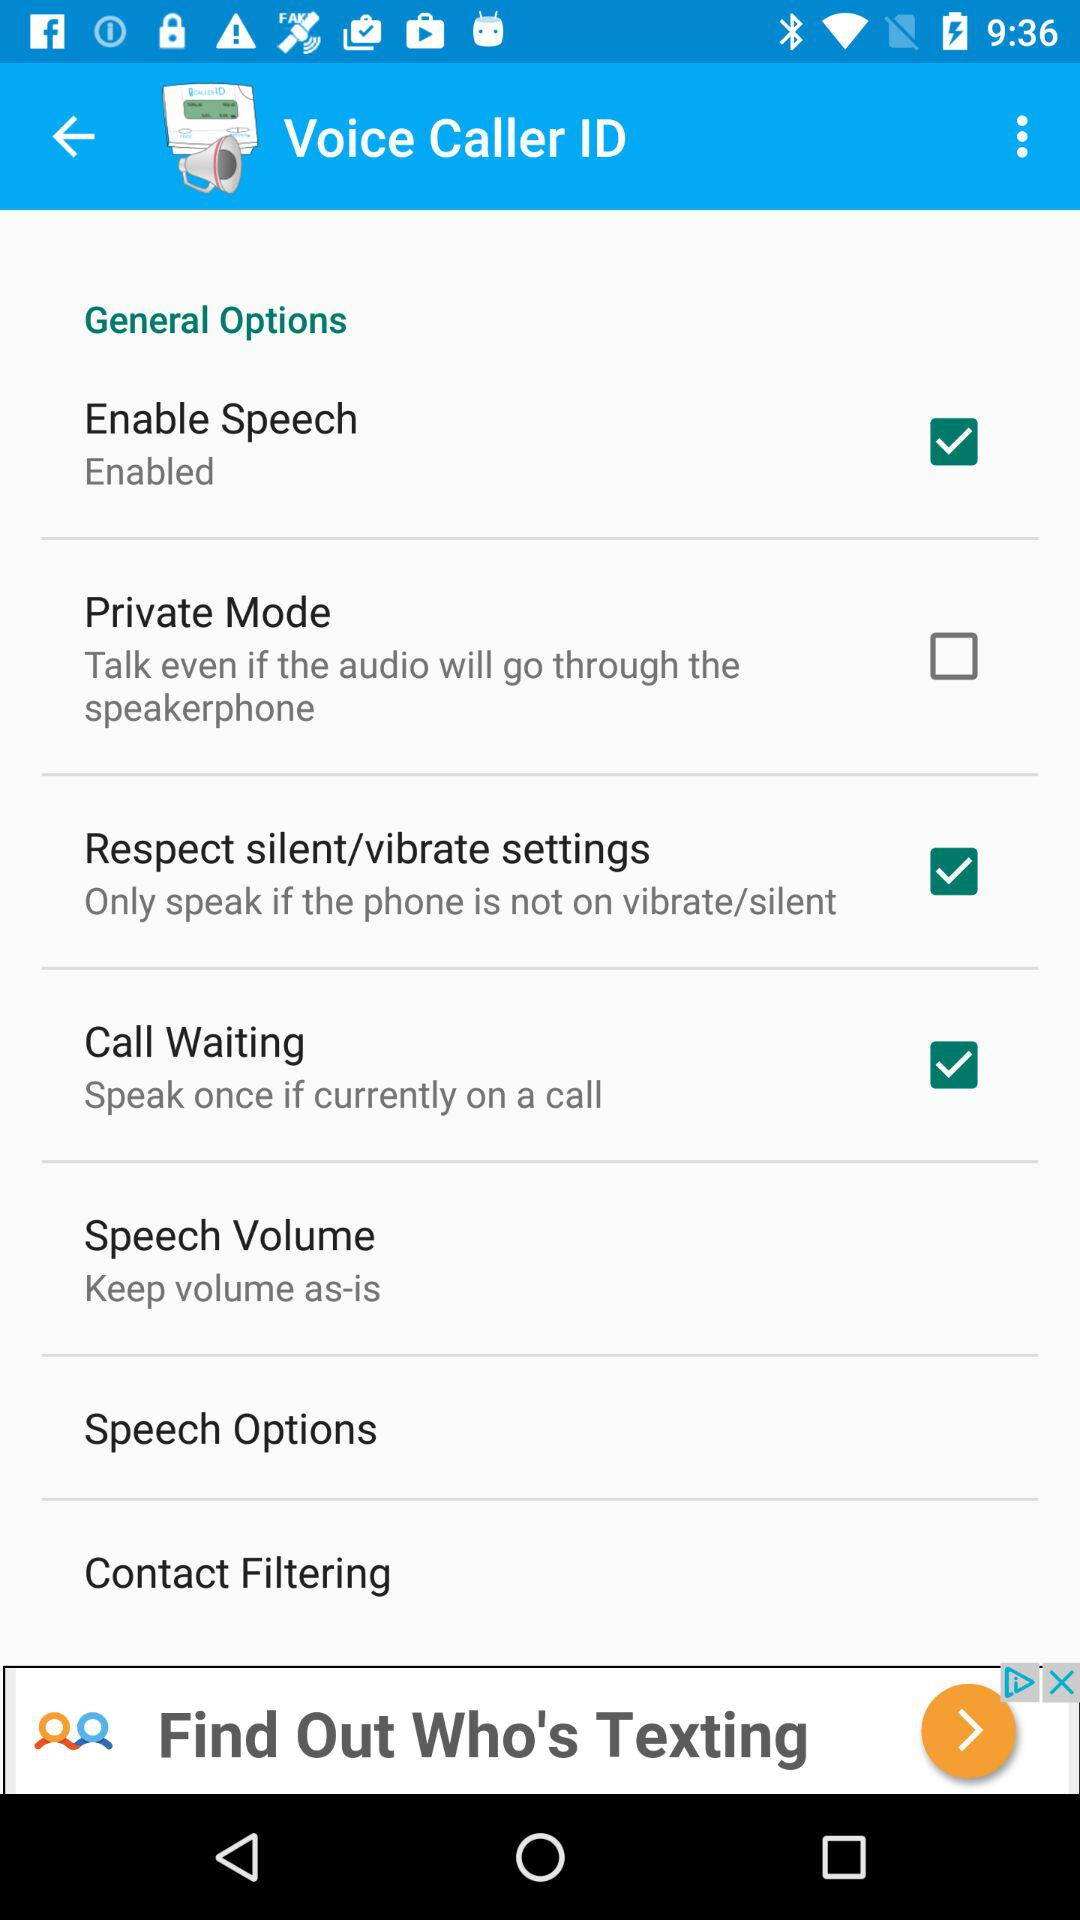What is the status of the enable speech? The status is on. 